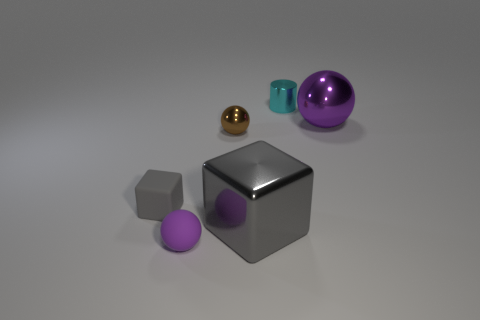There is a tiny object that is both on the right side of the tiny cube and in front of the tiny brown ball; what material is it made of?
Keep it short and to the point. Rubber. What number of gray things have the same size as the purple metallic ball?
Provide a short and direct response. 1. How many rubber objects are either purple spheres or balls?
Provide a succinct answer. 1. What material is the tiny cyan thing?
Your answer should be compact. Metal. What number of big blocks are behind the small brown metal object?
Ensure brevity in your answer.  0. Do the big thing that is in front of the purple metal sphere and the small brown ball have the same material?
Provide a succinct answer. Yes. What number of large gray objects are the same shape as the purple metallic thing?
Ensure brevity in your answer.  0. What number of large objects are either cylinders or matte spheres?
Give a very brief answer. 0. Do the ball in front of the shiny cube and the large ball have the same color?
Provide a succinct answer. Yes. There is a object in front of the big cube; does it have the same color as the big object that is behind the gray rubber object?
Give a very brief answer. Yes. 